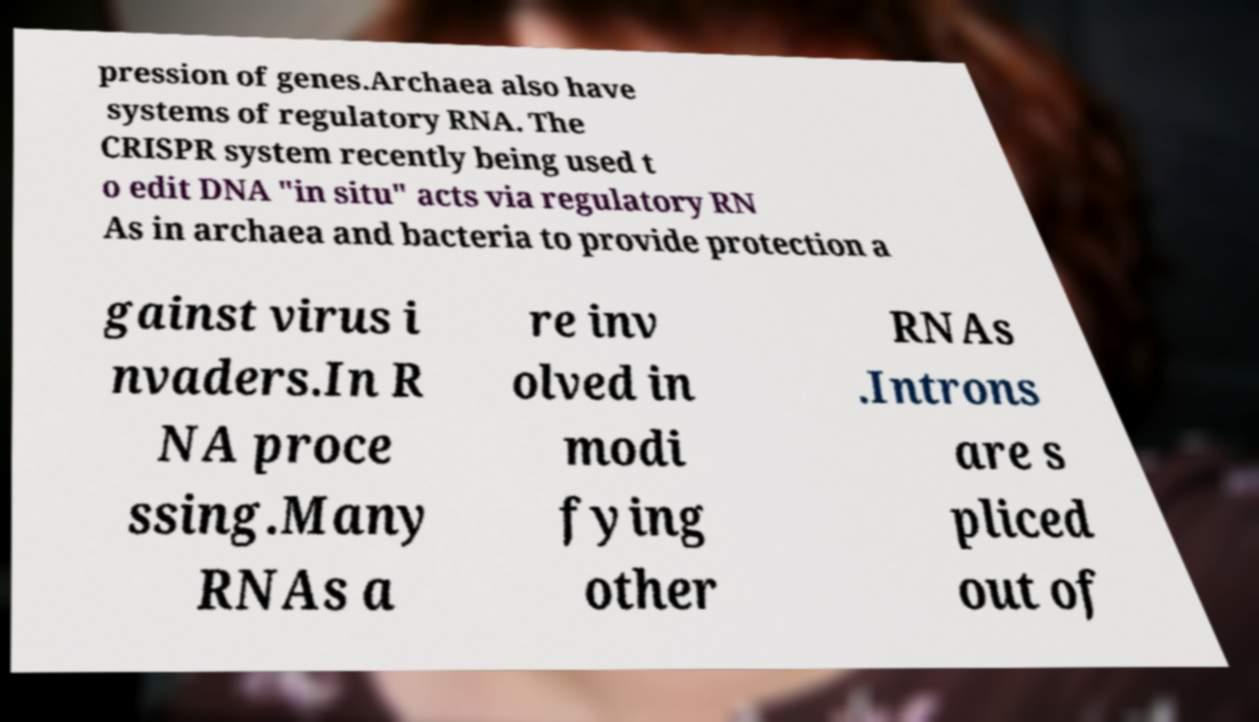What messages or text are displayed in this image? I need them in a readable, typed format. pression of genes.Archaea also have systems of regulatory RNA. The CRISPR system recently being used t o edit DNA "in situ" acts via regulatory RN As in archaea and bacteria to provide protection a gainst virus i nvaders.In R NA proce ssing.Many RNAs a re inv olved in modi fying other RNAs .Introns are s pliced out of 